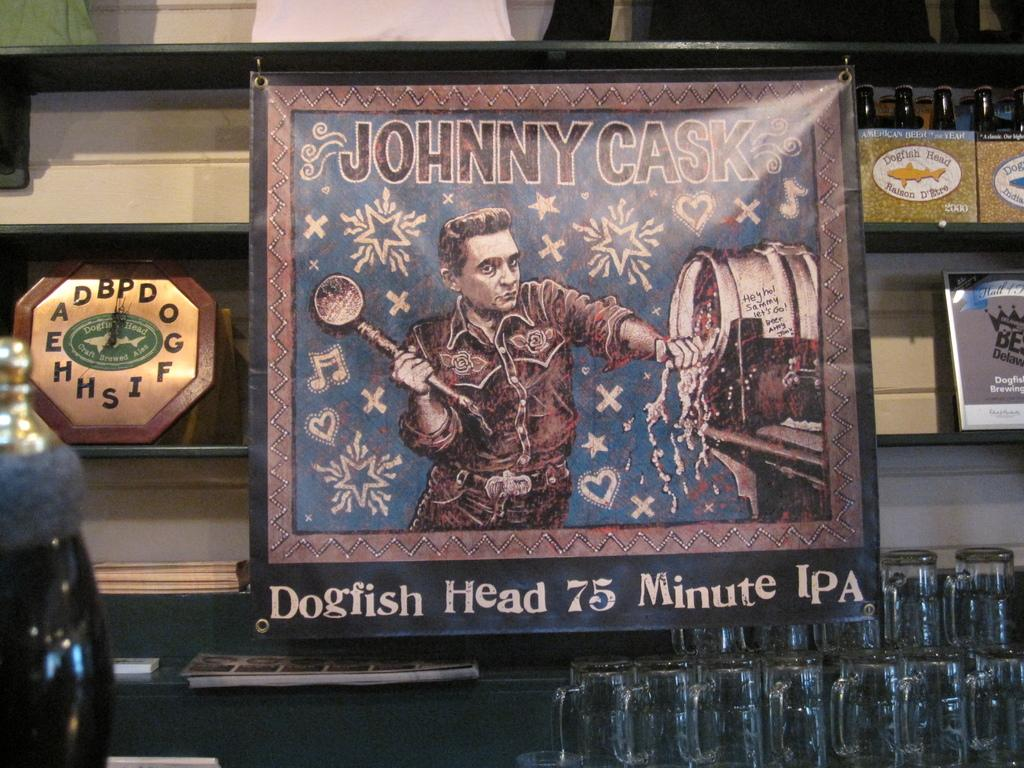<image>
Describe the image concisely. A piece of framed Art depicting Johnny Cask. 